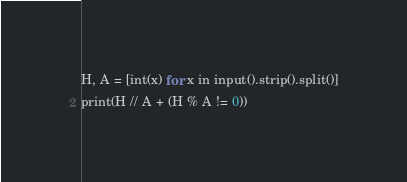Convert code to text. <code><loc_0><loc_0><loc_500><loc_500><_Python_>H, A = [int(x) for x in input().strip().split()]
print(H // A + (H % A != 0))</code> 